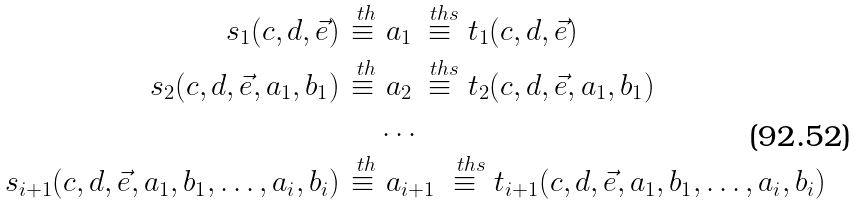Convert formula to latex. <formula><loc_0><loc_0><loc_500><loc_500>s _ { 1 } ( c , d , \vec { e } ) \stackrel { \ t h } { \equiv } & \ a _ { 1 } \stackrel { \ t h s } { \equiv } t _ { 1 } ( c , d , \vec { e } ) \\ s _ { 2 } ( c , d , \vec { e } , a _ { 1 } , b _ { 1 } ) \stackrel { \ t h } { \equiv } & \ a _ { 2 } \stackrel { \ t h s } { \equiv } t _ { 2 } ( c , d , \vec { e } , a _ { 1 } , b _ { 1 } ) \\ & \dots \\ s _ { i + 1 } ( c , d , \vec { e } , a _ { 1 } , b _ { 1 } , \dots , a _ { i } , b _ { i } ) \stackrel { \ t h } { \equiv } & \ a _ { i + 1 } \stackrel { \, \ t h s } { \equiv } t _ { i + 1 } ( c , d , \vec { e } , a _ { 1 } , b _ { 1 } , \dots , a _ { i } , b _ { i } )</formula> 